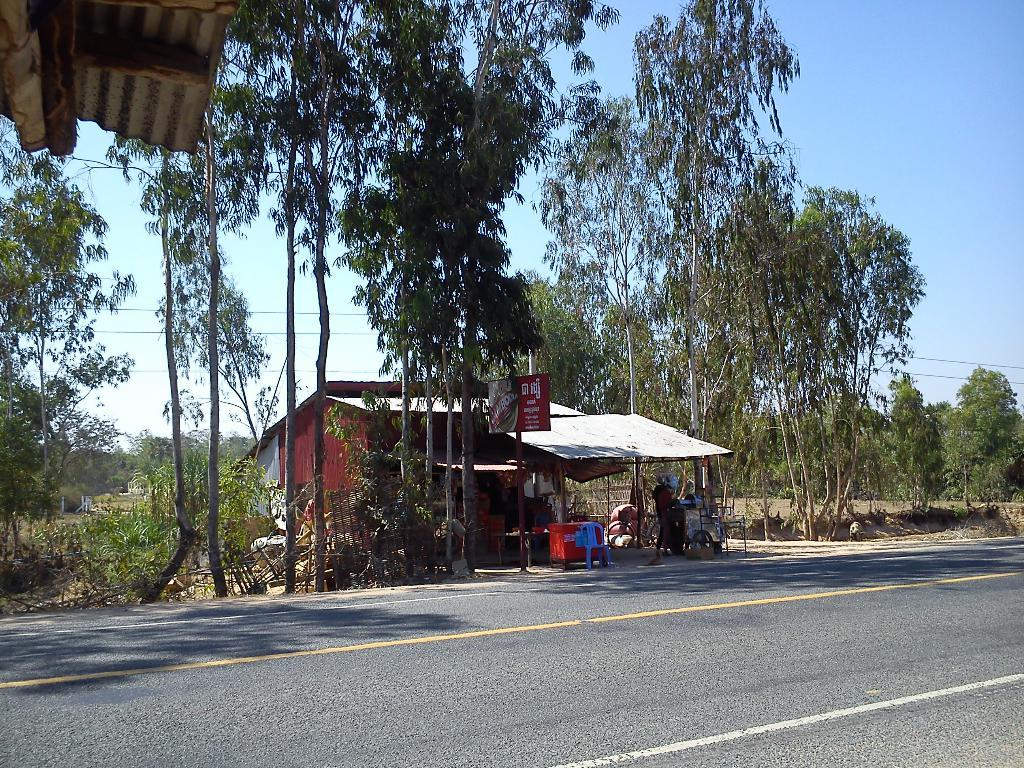What is the main feature of the image? There is a road in the image. What type of establishment can be seen in the image? There is a shop in the image. Can you describe the person in the image? There is a person in the image. What type of furniture is present in the image? There is a chair and a table in the image. What objects are made of wood in the image? There are wooden pieces in the image. What type of natural elements can be seen in the image? There are trees in the image. What structure is located at the top of the image? There is a shed at the top of the image. What is visible at the top of the image? The sky is visible at the top of the image. How many babies are crawling on the table in the image? There are no babies present in the image; it features a road, a shop, a person, a chair, a table, wooden pieces, trees, a shed, and the sky. What type of art is displayed on the chair in the image? There is no art displayed on the chair in the image; it is a regular chair with no decorations or paintings. 